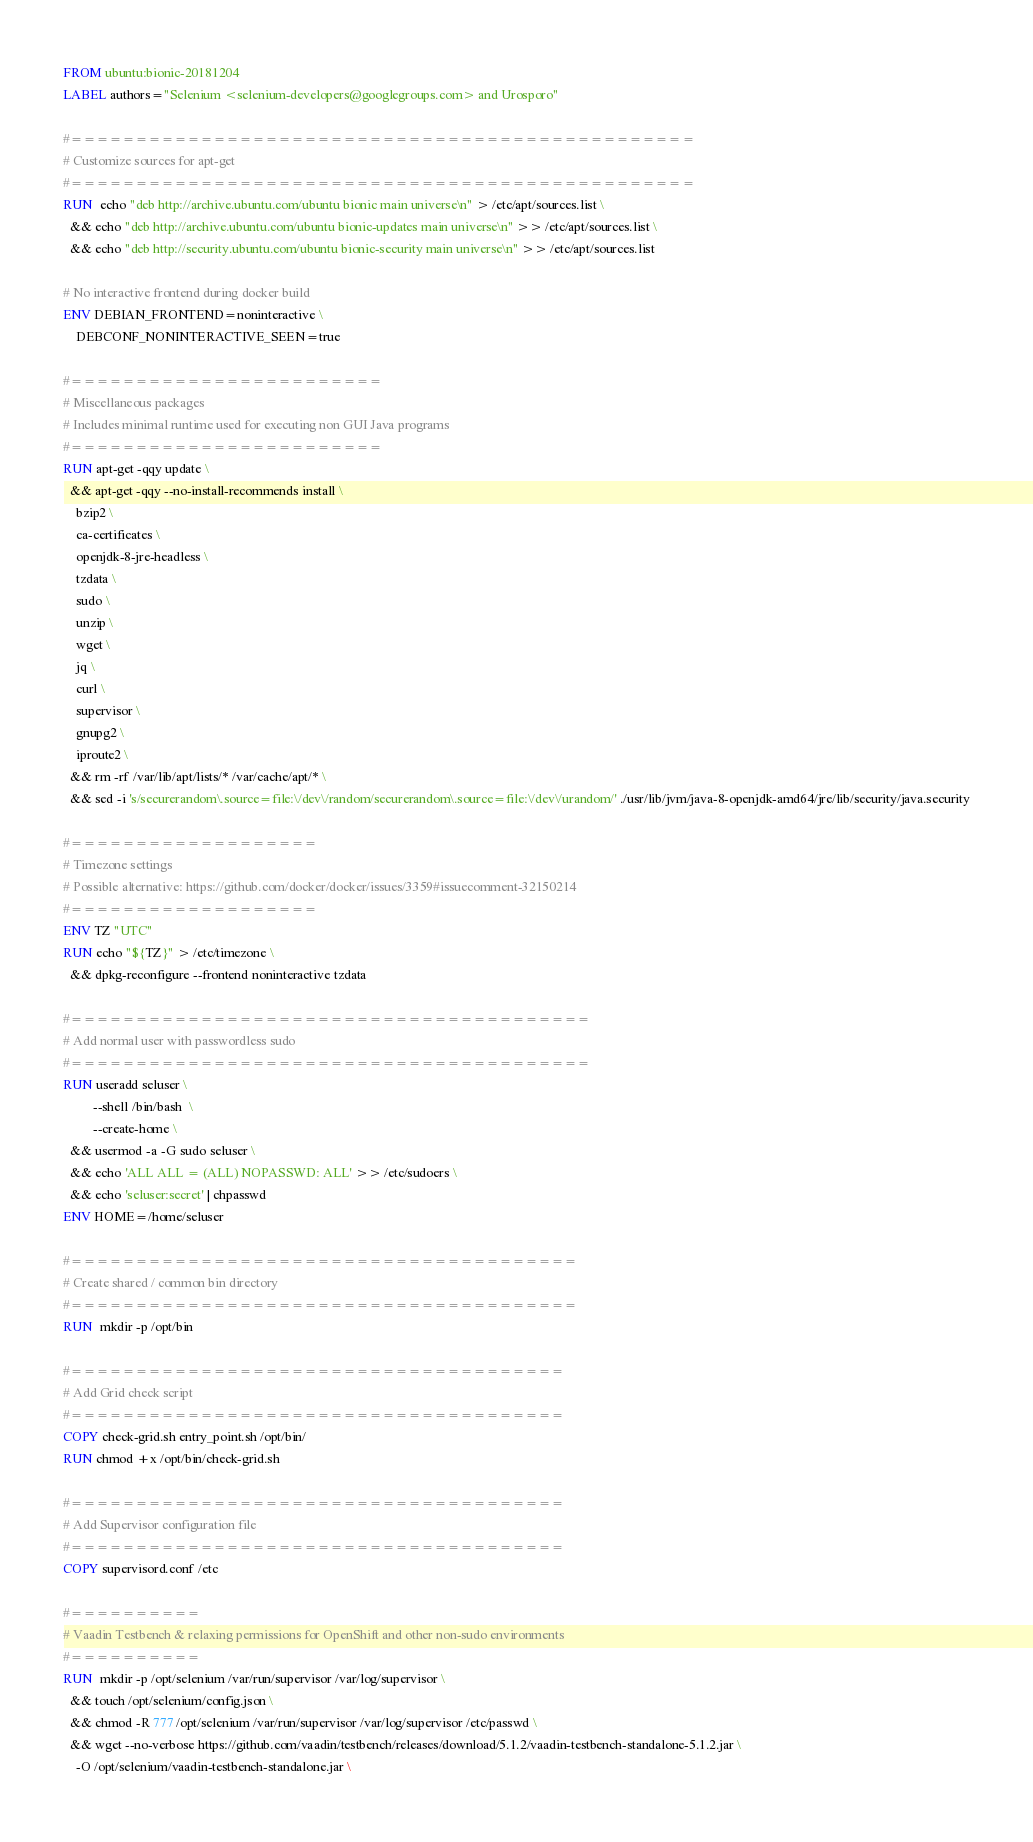Convert code to text. <code><loc_0><loc_0><loc_500><loc_500><_Dockerfile_>FROM ubuntu:bionic-20181204
LABEL authors="Selenium <selenium-developers@googlegroups.com> and Urosporo"

#================================================
# Customize sources for apt-get
#================================================
RUN  echo "deb http://archive.ubuntu.com/ubuntu bionic main universe\n" > /etc/apt/sources.list \
  && echo "deb http://archive.ubuntu.com/ubuntu bionic-updates main universe\n" >> /etc/apt/sources.list \
  && echo "deb http://security.ubuntu.com/ubuntu bionic-security main universe\n" >> /etc/apt/sources.list

# No interactive frontend during docker build
ENV DEBIAN_FRONTEND=noninteractive \
    DEBCONF_NONINTERACTIVE_SEEN=true

#========================
# Miscellaneous packages
# Includes minimal runtime used for executing non GUI Java programs
#========================
RUN apt-get -qqy update \
  && apt-get -qqy --no-install-recommends install \
    bzip2 \
    ca-certificates \
    openjdk-8-jre-headless \
    tzdata \
    sudo \
    unzip \
    wget \
    jq \
    curl \
    supervisor \
    gnupg2 \
    iproute2 \
  && rm -rf /var/lib/apt/lists/* /var/cache/apt/* \
  && sed -i 's/securerandom\.source=file:\/dev\/random/securerandom\.source=file:\/dev\/urandom/' ./usr/lib/jvm/java-8-openjdk-amd64/jre/lib/security/java.security

#===================
# Timezone settings
# Possible alternative: https://github.com/docker/docker/issues/3359#issuecomment-32150214
#===================
ENV TZ "UTC"
RUN echo "${TZ}" > /etc/timezone \
  && dpkg-reconfigure --frontend noninteractive tzdata

#========================================
# Add normal user with passwordless sudo
#========================================
RUN useradd seluser \
         --shell /bin/bash  \
         --create-home \
  && usermod -a -G sudo seluser \
  && echo 'ALL ALL = (ALL) NOPASSWD: ALL' >> /etc/sudoers \
  && echo 'seluser:secret' | chpasswd
ENV HOME=/home/seluser

#=======================================
# Create shared / common bin directory
#=======================================
RUN  mkdir -p /opt/bin 

#======================================
# Add Grid check script
#======================================
COPY check-grid.sh entry_point.sh /opt/bin/
RUN chmod +x /opt/bin/check-grid.sh

#======================================
# Add Supervisor configuration file
#======================================
COPY supervisord.conf /etc

#==========
# Vaadin Testbench & relaxing permissions for OpenShift and other non-sudo environments
#==========
RUN  mkdir -p /opt/selenium /var/run/supervisor /var/log/supervisor \
  && touch /opt/selenium/config.json \
  && chmod -R 777 /opt/selenium /var/run/supervisor /var/log/supervisor /etc/passwd \
  && wget --no-verbose https://github.com/vaadin/testbench/releases/download/5.1.2/vaadin-testbench-standalone-5.1.2.jar \
    -O /opt/selenium/vaadin-testbench-standalone.jar \</code> 